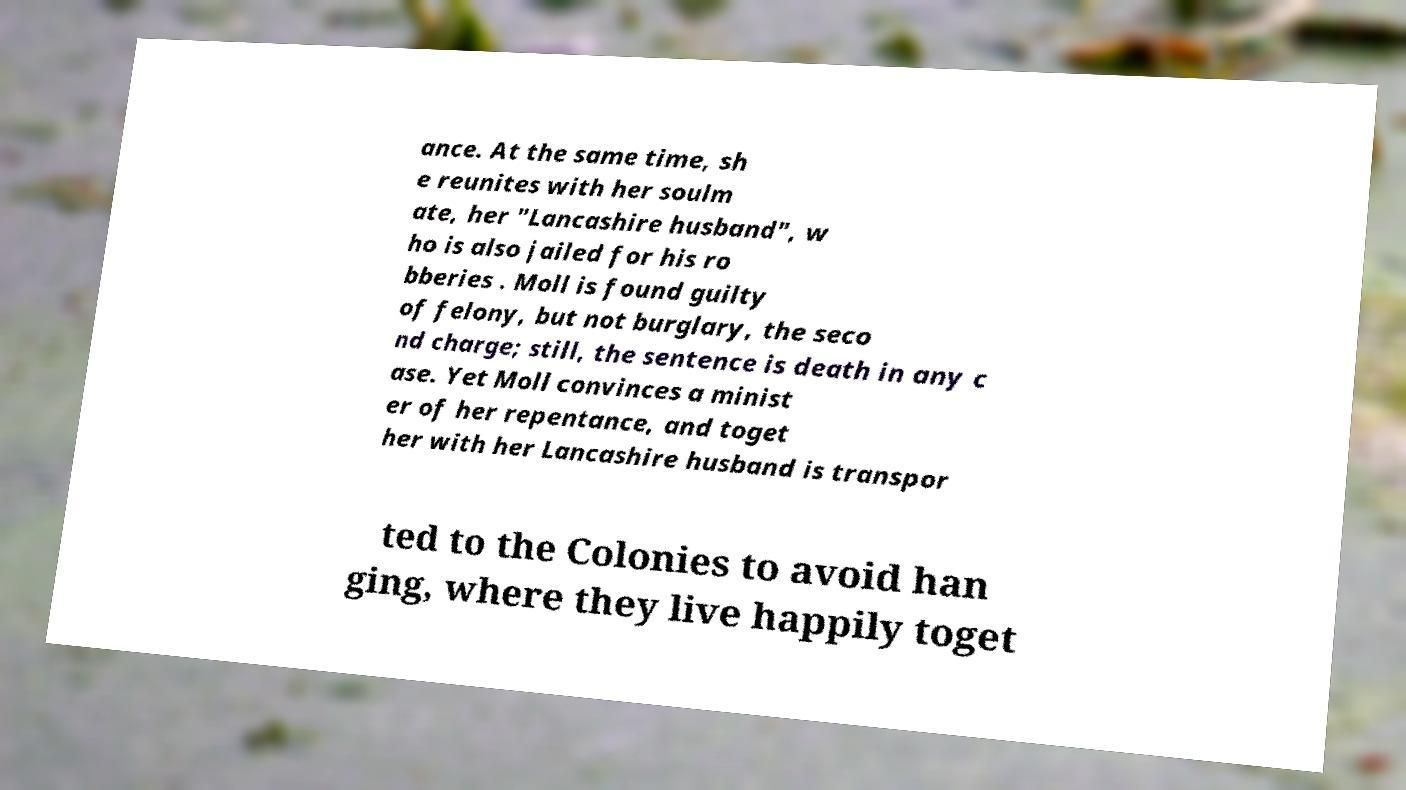Can you read and provide the text displayed in the image?This photo seems to have some interesting text. Can you extract and type it out for me? ance. At the same time, sh e reunites with her soulm ate, her "Lancashire husband", w ho is also jailed for his ro bberies . Moll is found guilty of felony, but not burglary, the seco nd charge; still, the sentence is death in any c ase. Yet Moll convinces a minist er of her repentance, and toget her with her Lancashire husband is transpor ted to the Colonies to avoid han ging, where they live happily toget 